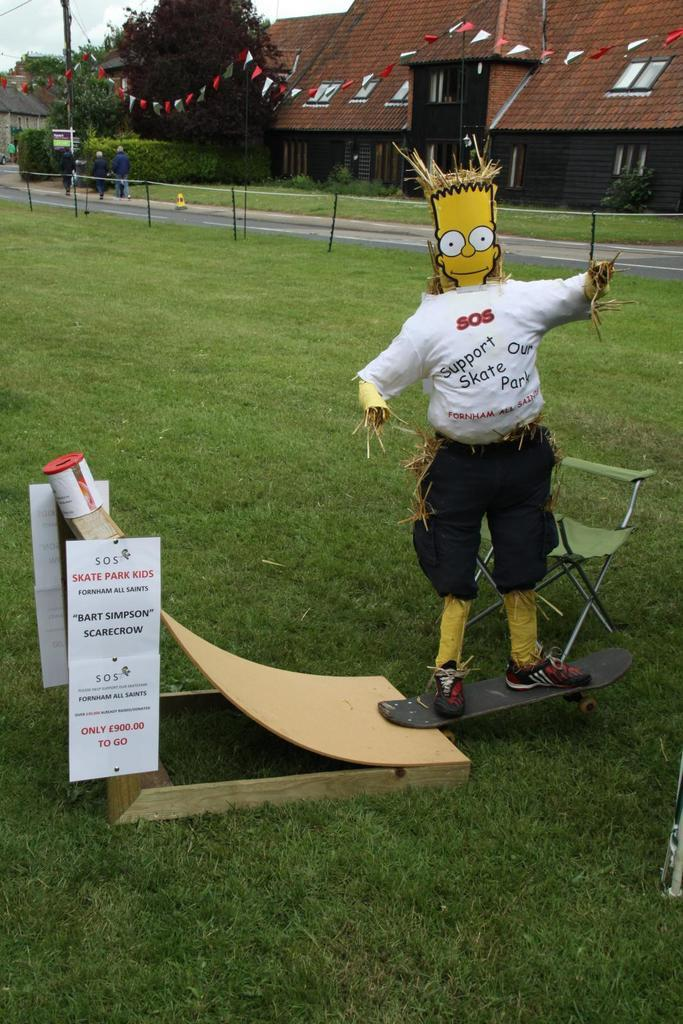What object can be found on the right side of the image? There is a chair, a scarecrow, and a skateboard on the right side of the image. What type of vegetation is visible in the background of the image? There is grass in the background of the image. What architectural features can be seen in the background of the image? There is fencing, houses, and a pole in the background of the image. What else can be seen in the background of the image? There are trees, persons, a road, and sky visible in the background of the image. What type of lamp is hanging from the scarecrow in the image? There is no lamp present in the image, and the scarecrow does not have any lamps attached to it. 